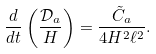Convert formula to latex. <formula><loc_0><loc_0><loc_500><loc_500>\frac { d } { d t } \left ( \frac { \mathcal { D } _ { a } } { H } \right ) = \frac { \tilde { C } _ { a } } { 4 H ^ { 2 } \ell ^ { 2 } } .</formula> 